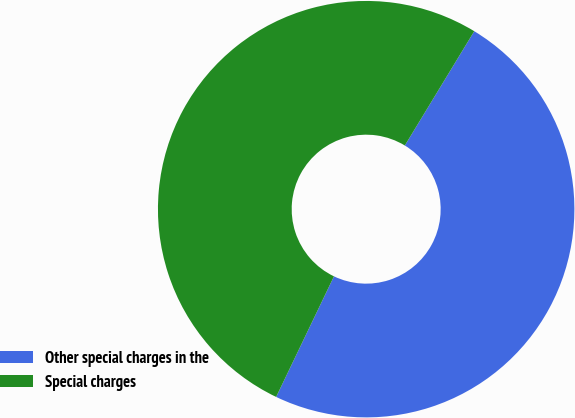Convert chart. <chart><loc_0><loc_0><loc_500><loc_500><pie_chart><fcel>Other special charges in the<fcel>Special charges<nl><fcel>48.43%<fcel>51.57%<nl></chart> 